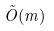Convert formula to latex. <formula><loc_0><loc_0><loc_500><loc_500>\tilde { O } ( m )</formula> 